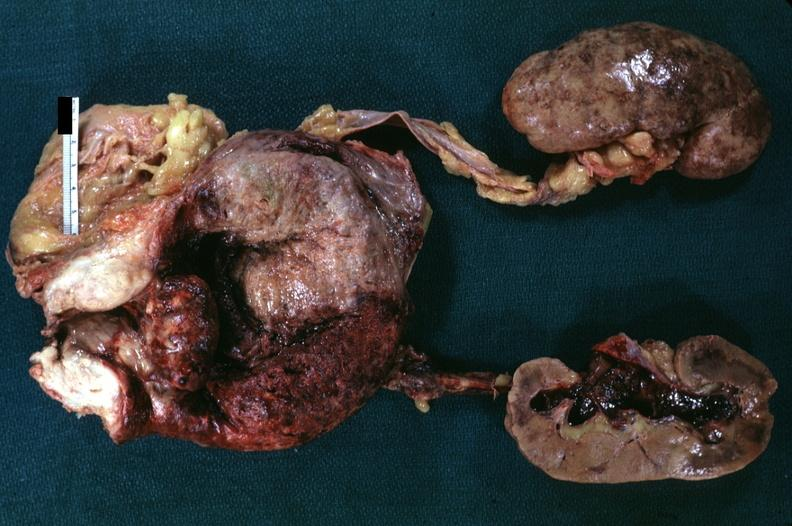what appear normal focal hemorrhages in kidneys and hemorrhagic pyelitis indicates pyelonephritis carcinoma in prostate is diagnosis but can not?
Answer the question using a single word or phrase. Median lobe hyperplasia with marked cystitis bladder hypertrophy ureter 